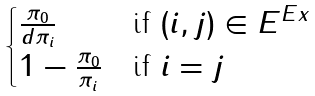<formula> <loc_0><loc_0><loc_500><loc_500>\begin{cases} \frac { \pi _ { 0 } } { d \pi _ { i } } & \text {if } ( i , j ) \in E ^ { E x } \\ 1 - \frac { \pi _ { 0 } } { \pi _ { i } } & \text {if } i = j \\ \end{cases}</formula> 